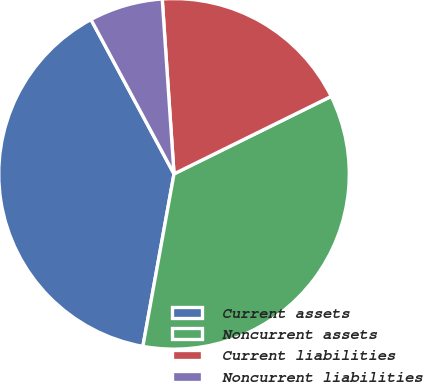<chart> <loc_0><loc_0><loc_500><loc_500><pie_chart><fcel>Current assets<fcel>Noncurrent assets<fcel>Current liabilities<fcel>Noncurrent liabilities<nl><fcel>39.3%<fcel>35.13%<fcel>18.78%<fcel>6.78%<nl></chart> 